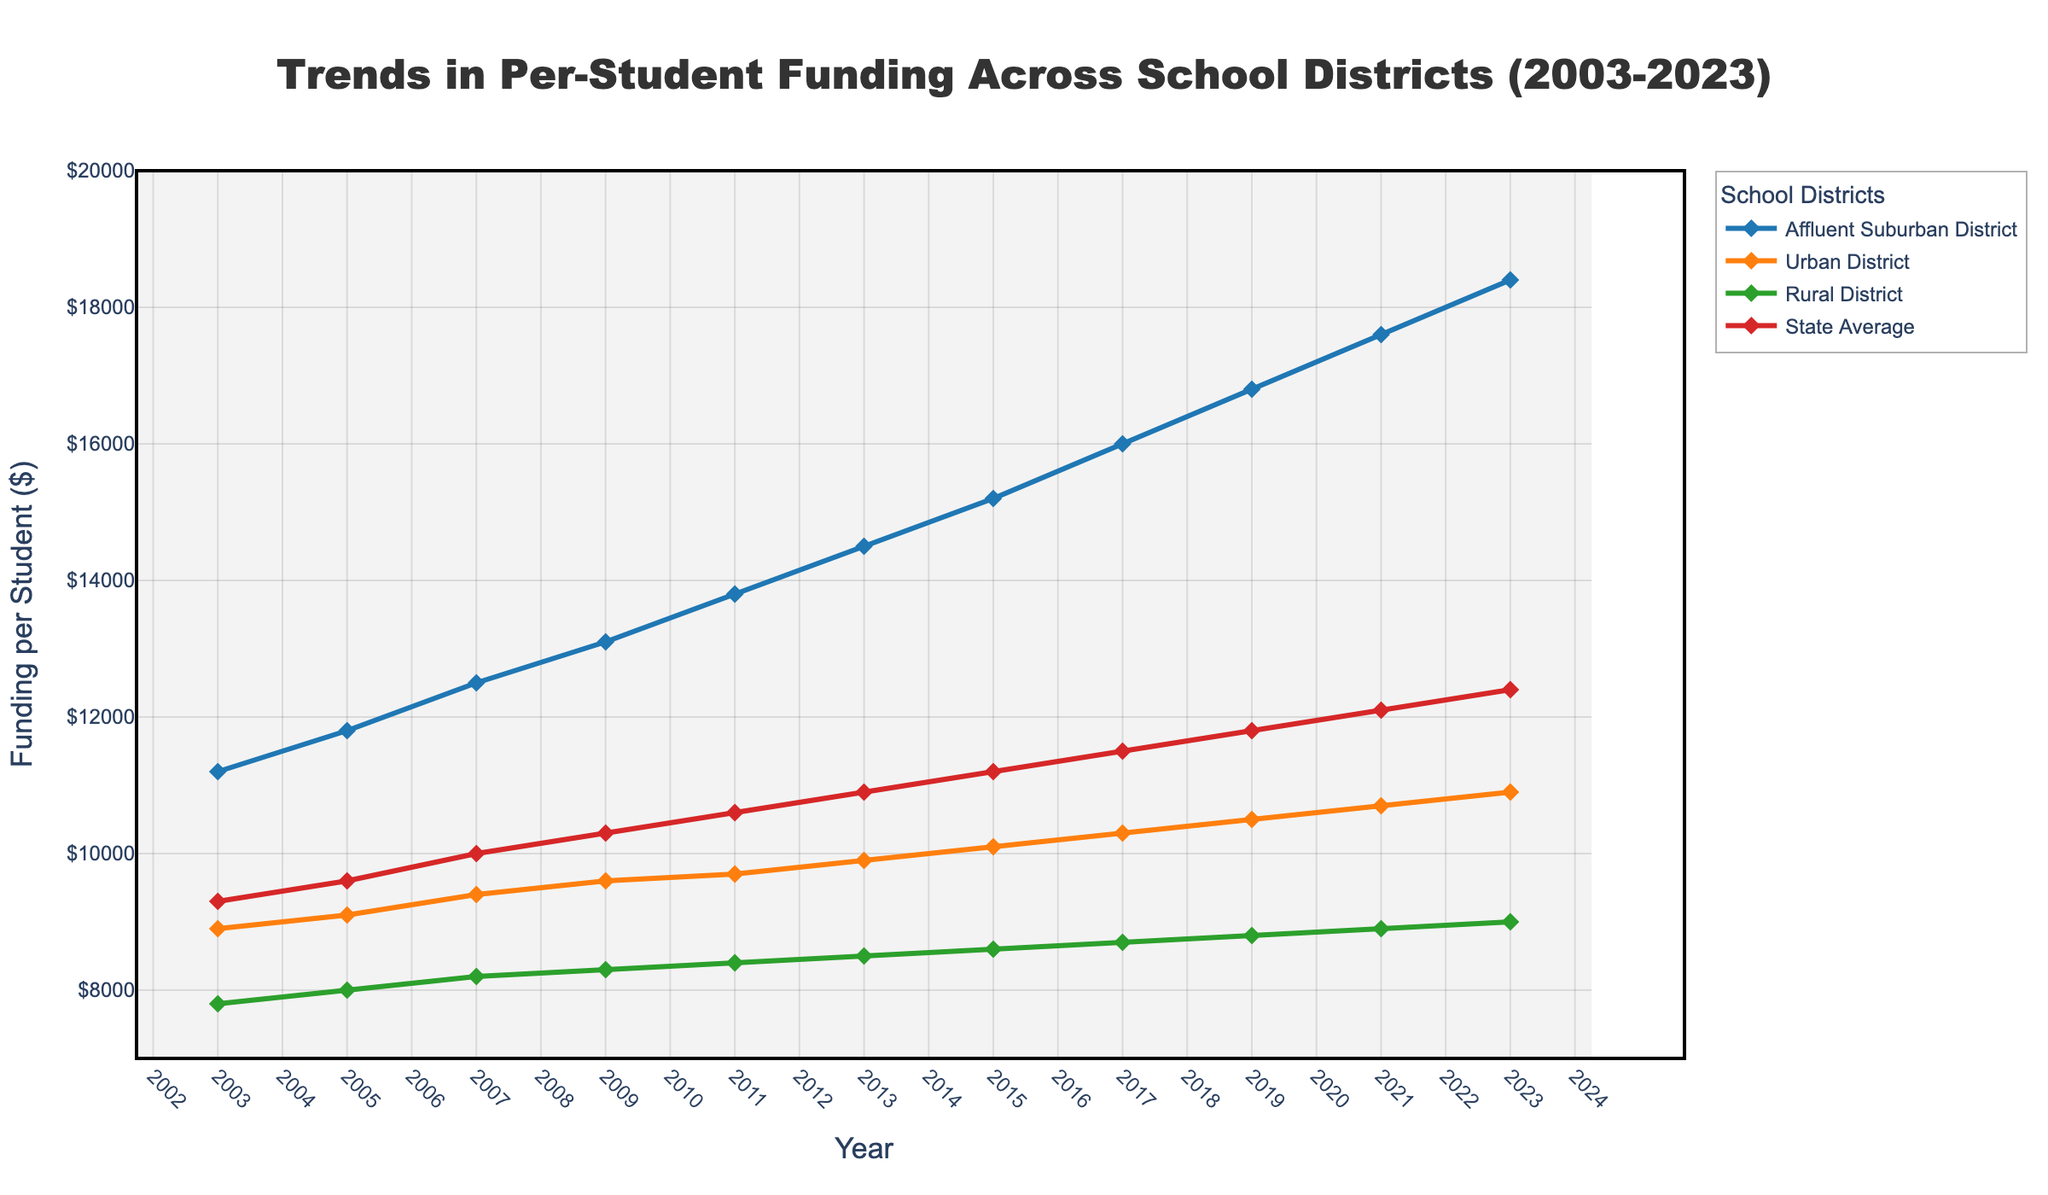What is the overall trend in funding for the Affluent Suburban District from 2003 to 2023? The line representing the Affluent Suburban District shows a consistent upward trajectory from $11,200 in 2003 to $18,400 in 2023, indicating an increase in funding over the 20-year period.
Answer: Increasing How does the funding in the Urban District in 2023 compare to that in the Rural District in the same year? In 2023, the point for the Urban District is at $10,900, while the point for the Rural District is at $9,000, showing that the Urban District has higher funding.
Answer: Urban District has higher funding What is the average increase in funding for the State Average from 2003 to 2023? Calculate the difference between the funding in 2023 and 2003 for the State Average ($12,400 - $9,300) which equals $3,100, and divide this by the number of years (20) to find the average annual increase.
Answer: $155 Which district has the most significant increase in per-student funding over the period shown? By comparing the slopes of the lines, the Affluent Suburban District shows the most significant increase in funding, rising from $11,200 to $18,400, which is an increase of $7,200.
Answer: Affluent Suburban District Is there any point where the funding for the Urban District is equal to the funding for the Rural District? By tracing the lines for the Urban and Rural Districts, you can see that there is no point where these lines intersect, indicating that their funding levels never match.
Answer: No Among the districts, which one shows the slowest growth in funding per student from 2003 to 2023? By comparing the slopes of all lines, the Rural District shows the slowest growth, from $7,800 in 2003 to $9,000 in 2023, an increase of $1,200.
Answer: Rural District How does the funding in the year 2015 for the Affluent Suburban District compare to the State Average's funding in the same year? In 2015, the point for the Affluent Suburban District is at $15,200, while the State Average is at $11,200, indicating that the Affluent Suburban District has significantly higher funding.
Answer: Affluent Suburban is higher What is the difference in funding between the Affluent Suburban District and Rural District in 2017? Subtract the Rural District's funding in 2017 ($8,700) from the Affluent Suburban District's funding in 2017 ($16,000) to get the difference.
Answer: $7,300 Between the years 2011 and 2013, which district experienced the highest percentage increase in funding? Calculate the percentage increase for each district using the formula [(2013 value - 2011 value) / 2011 value] * 100. The Affluent Suburban District has the largest percentage increase: [(14500 - 13800) / 13800] * 100.
Answer: Affluent Suburban District 